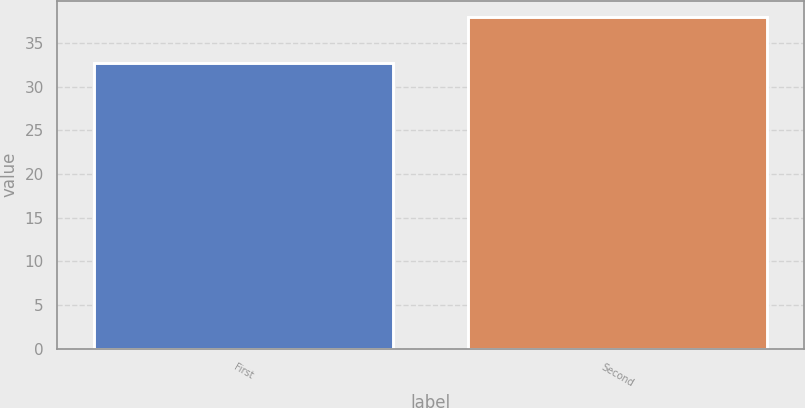Convert chart to OTSL. <chart><loc_0><loc_0><loc_500><loc_500><bar_chart><fcel>First<fcel>Second<nl><fcel>32.72<fcel>37.92<nl></chart> 